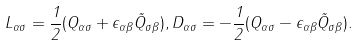Convert formula to latex. <formula><loc_0><loc_0><loc_500><loc_500>L _ { \alpha \sigma } = \frac { 1 } { 2 } ( Q _ { \alpha \sigma } + \epsilon _ { \alpha \beta } \tilde { Q } _ { \sigma \beta } ) , D _ { \alpha \sigma } = - \frac { 1 } { 2 } ( Q _ { \alpha \sigma } - \epsilon _ { \alpha \beta } \tilde { Q } _ { \sigma \beta } ) .</formula> 